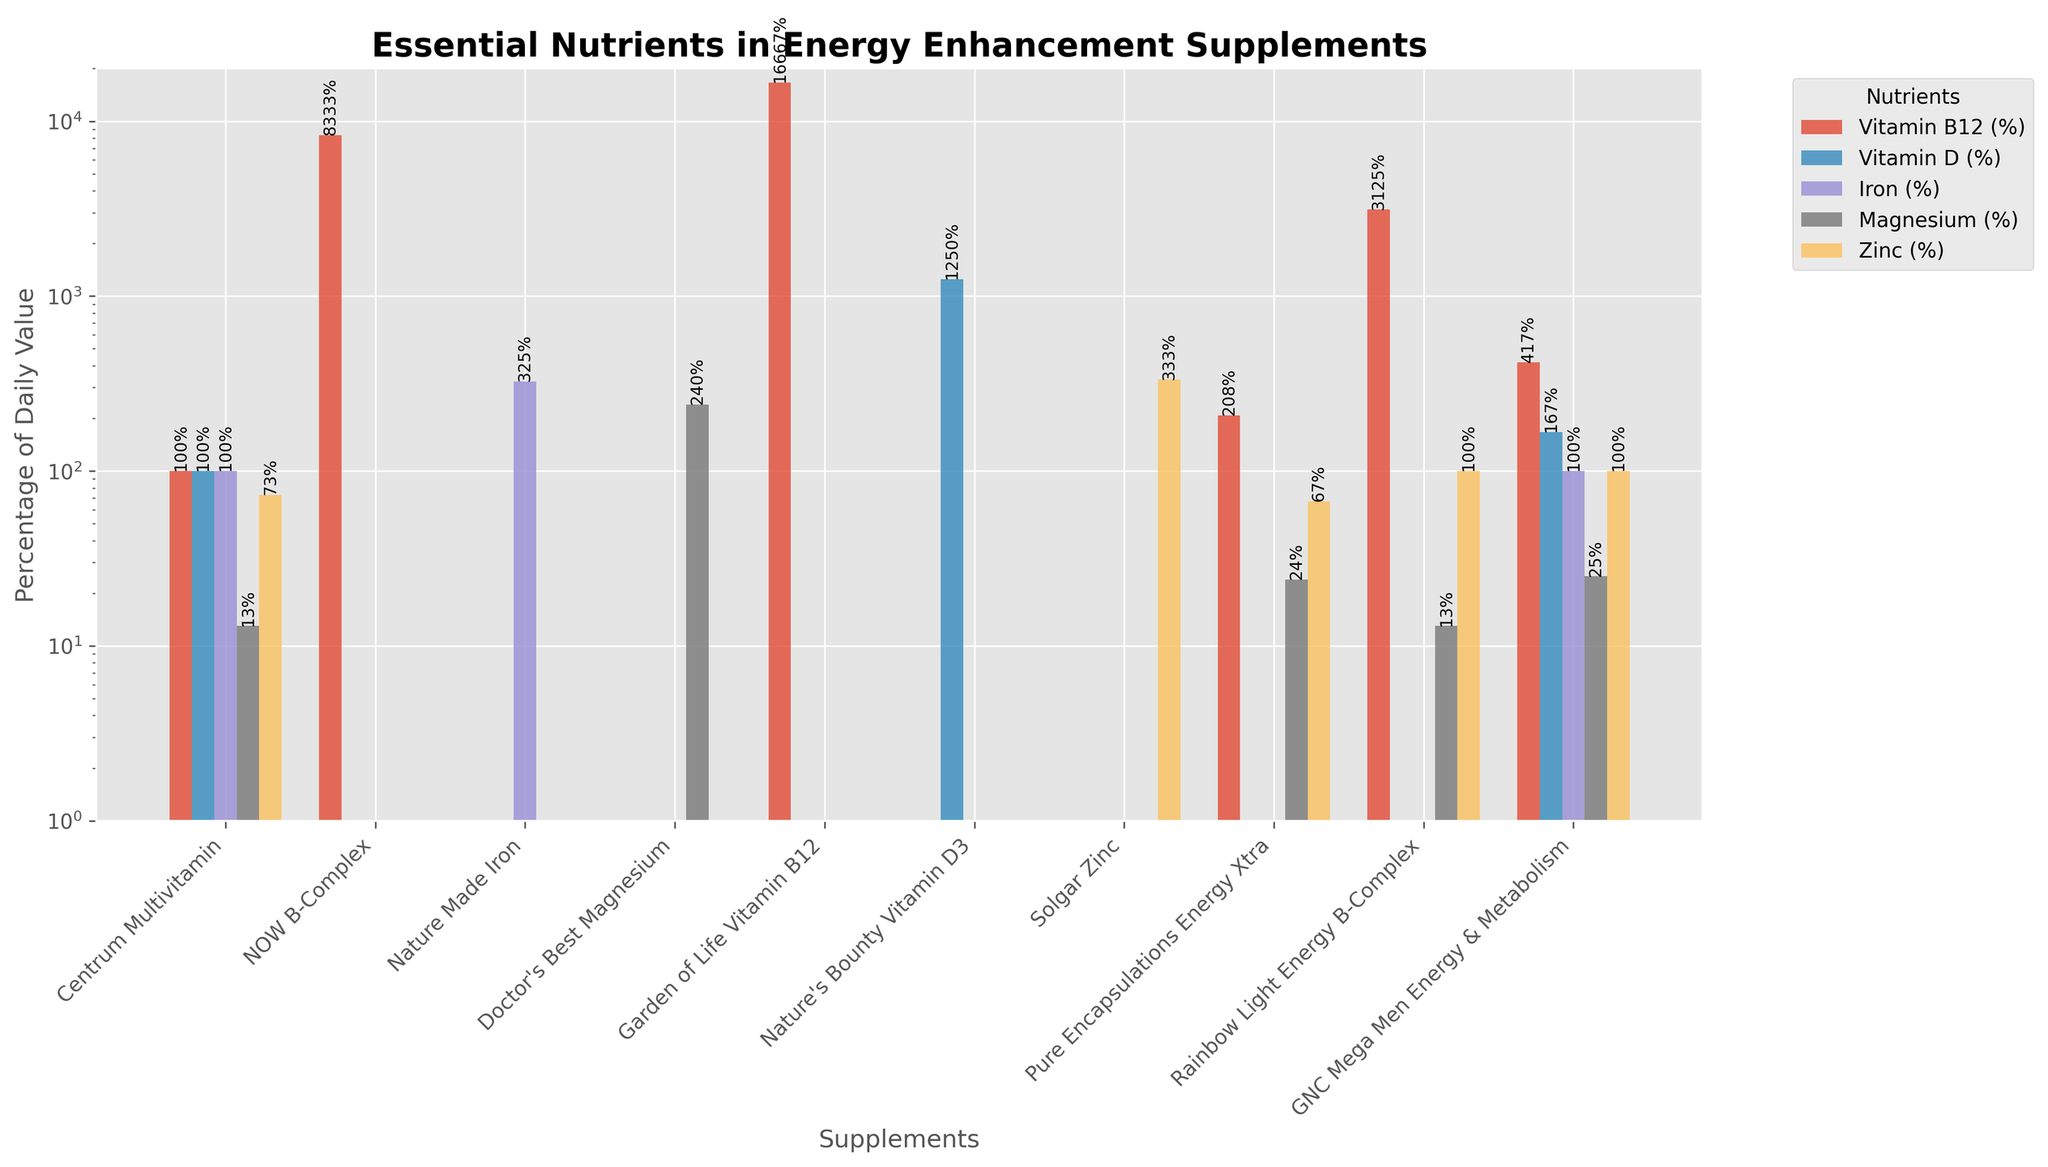Which supplement has the highest percentage of Vitamin B12? By visually scanning the height of the bars corresponding to Vitamin B12 (likely in orange) and comparing their heights, it's evident that Garden of Life Vitamin B12 has the highest percentage.
Answer: Garden of Life Vitamin B12 Which supplement provides the highest percentage of Zinc? Visual inspection of the bars corresponding to Zinc (likely in blue) reveals that Solgar Zinc has the highest percentage of Zinc.
Answer: Solgar Zinc How many supplements provide more than 100% of the daily value for Vitamin D? By checking the heights of the bars corresponding to Vitamin D (likely in green) and counting those that are taller than the 100% mark, we see that Nature's Bounty Vitamin D3 and GNC Mega Men Energy & Metabolism are above 100%.
Answer: 2 What is the total percentage of Iron provided by Centrum Multivitamin and Nature Made Iron combined? The height of the bar for Iron (likely in red) for Centrum Multivitamin is 100%, and for Nature Made Iron is 325%. Adding them together gives 425%.
Answer: 425% Which supplement has the most evenly distributed essential nutrients? By observing the bars for each supplement, Centrum Multivitamin has all five nutrients in relatively even amounts compared to others that have high values in only one or two nutrients.
Answer: Centrum Multivitamin Compare the percentage of Vitamin B12 in NOW B-Complex and Pure Encapsulations Energy Xtra. Which provides more, and by how much? NOW B-Complex has 8333% and Pure Encapsulations Energy Xtra has 208%. The difference is 8333% - 208% = 8125%.
Answer: NOW B-Complex, 8125% Which two supplements provide similar levels of Magnesium? By comparing the heights of the bars corresponding to Magnesium (likely in purple), we see that Pure Encapsulations Energy Xtra and GNC Mega Men Energy & Metabolism provide similar levels (24% and 25%, respectively).
Answer: Pure Encapsulations Energy Xtra, GNC Mega Men Energy & Metabolism What is the average percentage of Zinc in supplements containing it? The zinc percentages visible are 73%, 67%, 100%, and 333%. The average is (73 + 67 + 100 + 333) / 4 = 573 / 4 = 143.25%.
Answer: 143.25% What is the difference in the percentage of Vitamin D between Nature's Bounty Vitamin D3 and GNC Mega Men Energy & Metabolism? Nature's Bounty Vitamin D3 has 1250%, while GNC Mega Men Energy & Metabolism has 167%. The difference is 1250% - 167% = 1083%.
Answer: 1083% Which two nutrients are provided by the most number of supplements? By counting the number of bars for each nutrient across all supplements, Vitamin B12 and Magnesium are the most frequently present nutrients.
Answer: Vitamin B12, Magnesium 